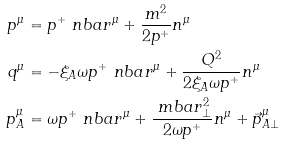<formula> <loc_0><loc_0><loc_500><loc_500>p ^ { \mu } & = p ^ { + } \ n b a r ^ { \mu } + \frac { m ^ { 2 } } { 2 p ^ { + } } n ^ { \mu } \\ q ^ { \mu } & = - \xi _ { A } \omega p ^ { + } \ n b a r ^ { \mu } + \frac { Q ^ { 2 } } { 2 \xi _ { A } \omega p ^ { + } } n ^ { \mu } \\ p _ { A } ^ { \mu } & = \omega p ^ { + } \ n b a r ^ { \mu } + \frac { \ m b a r _ { \perp } ^ { 2 } } { 2 \omega p ^ { + } } n ^ { \mu } + \vec { p } _ { A \perp } ^ { \mu }</formula> 